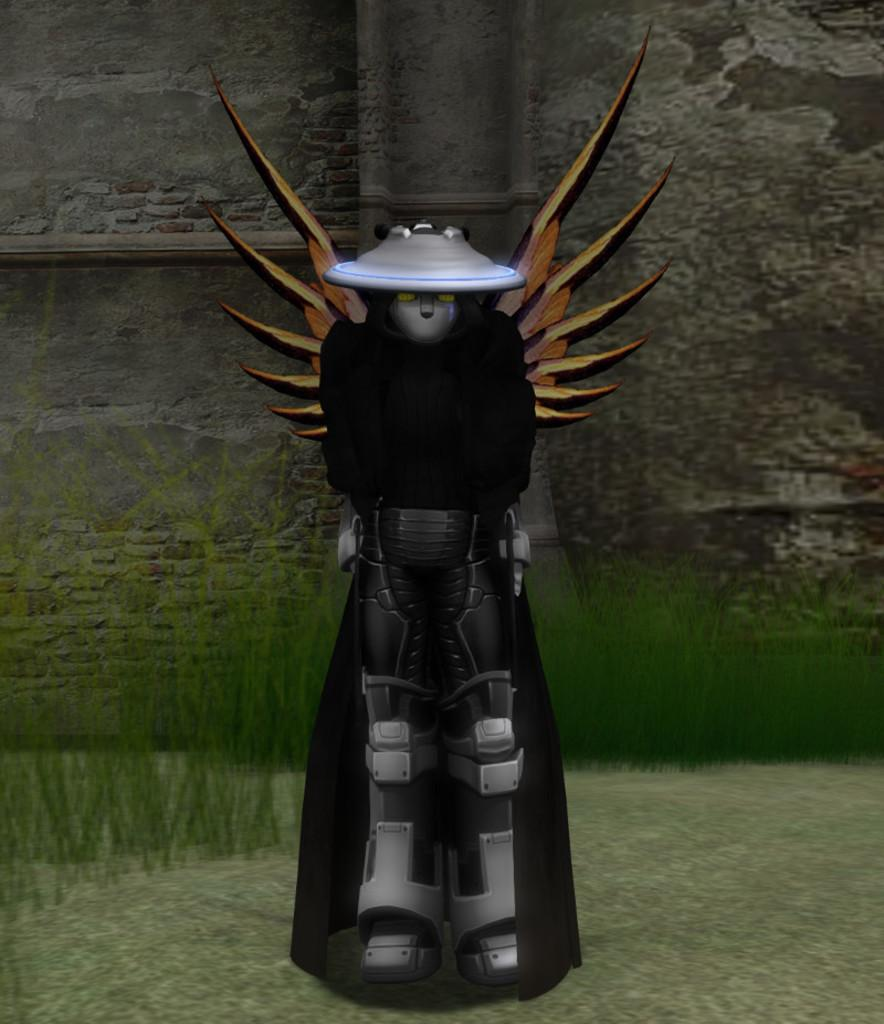What is the main subject of the image? There is a person standing in the image. What can be seen behind the person? There is a wall behind the person. What type of ground is visible in the image? There is grass on the ground in the image. What type of cracker is being exchanged between the person and the wall in the image? There is no cracker or exchange present in the image; it only features a person standing in front of a wall with grass on the ground. 